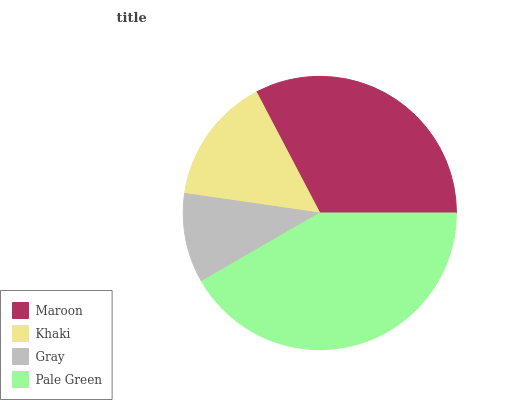Is Gray the minimum?
Answer yes or no. Yes. Is Pale Green the maximum?
Answer yes or no. Yes. Is Khaki the minimum?
Answer yes or no. No. Is Khaki the maximum?
Answer yes or no. No. Is Maroon greater than Khaki?
Answer yes or no. Yes. Is Khaki less than Maroon?
Answer yes or no. Yes. Is Khaki greater than Maroon?
Answer yes or no. No. Is Maroon less than Khaki?
Answer yes or no. No. Is Maroon the high median?
Answer yes or no. Yes. Is Khaki the low median?
Answer yes or no. Yes. Is Gray the high median?
Answer yes or no. No. Is Pale Green the low median?
Answer yes or no. No. 